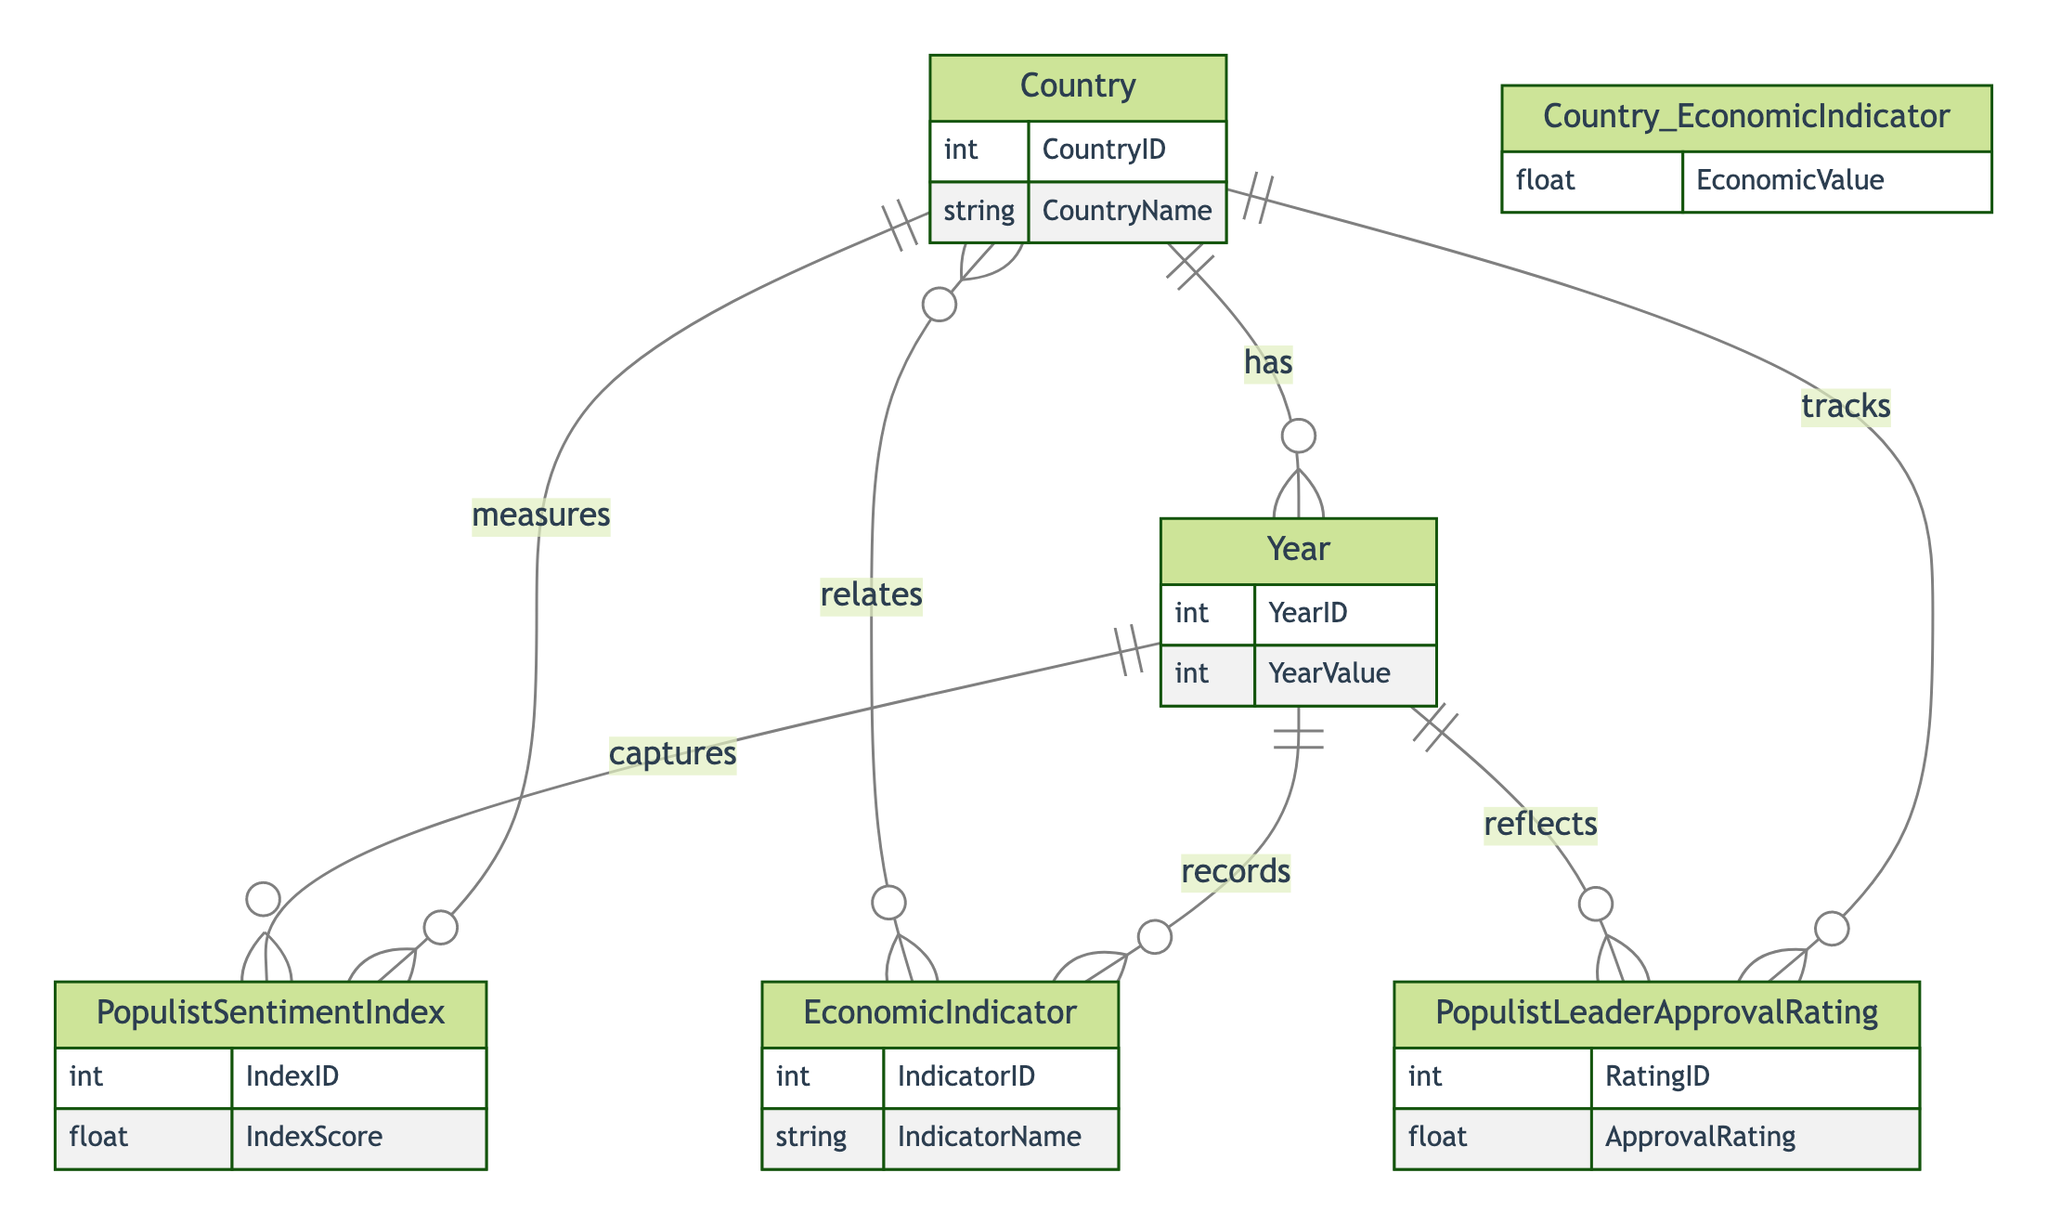What entities are present in the diagram? The diagram contains five entities: Country, Economic Indicator, Year, Populist Sentiment Index, and Populist Leader Approval Rating. These entities are crucial for understanding the relationships among economic performance, populist sentiment, and related metrics.
Answer: Country, Economic Indicator, Year, Populist Sentiment Index, Populist Leader Approval Rating How many relationships connect Country and Economic Indicator? There is one Many-to-Many relationship between Country and Economic Indicator, as indicated by the diagram. This means that multiple countries can be associated with multiple economic indicators, facilitating a rich analysis of economic data across different contexts.
Answer: One What is the relationship type between Country and Year? The relationship between Country and Year is One-to-Many. This indicates that each country can have multiple year records associated with it, allowing for longitudinal studies of economic indicators, sentiment indices, and approval ratings over time.
Answer: One-to-Many How many attributes does the Populist Sentiment Index have? The Populist Sentiment Index has two attributes: IndexID and IndexScore. These attributes help in quantifying and identifying the levels of populist sentiment in different countries and years.
Answer: Two What is the significance of the Year entity in the diagram? The Year entity plays a pivotal role in the diagram as it connects multiple relationships, acting as an anchor for economic indicators and populist sentiment metrics. It allows for the analysis of how these factors evolve over time in each country, enhancing the understanding of temporal dynamics in populism.
Answer: Anchor for time analysis Which relationship reflects the approval rating of populist leaders? The relationship that reflects the approval rating of populist leaders is the One-to-Many relationship between Country and Populist Leader Approval Rating, and also the One-to-Many between Year and Populist Leader Approval Rating, indicating that each country and year can record multiple approval ratings.
Answer: Country_PopulistLeaderApprovalRating, Year_PopulistLeaderApprovalRating How many Economic Indicators can a single Year record? A single Year can record multiple Economic Indicators due to the One-to-Many relationship between Year and Economic Indicator. This allows for a diverse range of economic metrics to be associated with specific year records, which is essential for comprehensive economic analyses over time.
Answer: Multiple What does the EconomicValue attribute represent in the diagram? The EconomicValue attribute represents the quantifiable measure of economic performance related between a country and its economic indicator, serving as a vital data point for analyzing the implications of economic circumstances on populist sentiment and leader approval ratings.
Answer: Measure of economic performance 